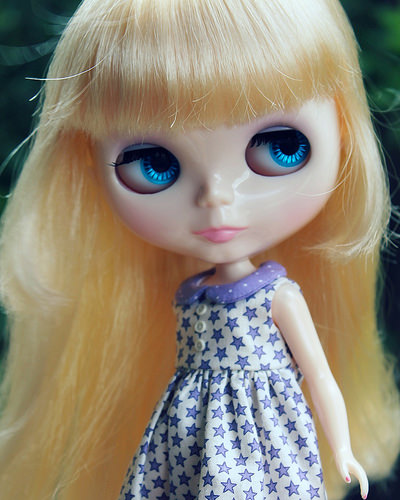<image>
Is the fake eye in the doll? Yes. The fake eye is contained within or inside the doll, showing a containment relationship. 